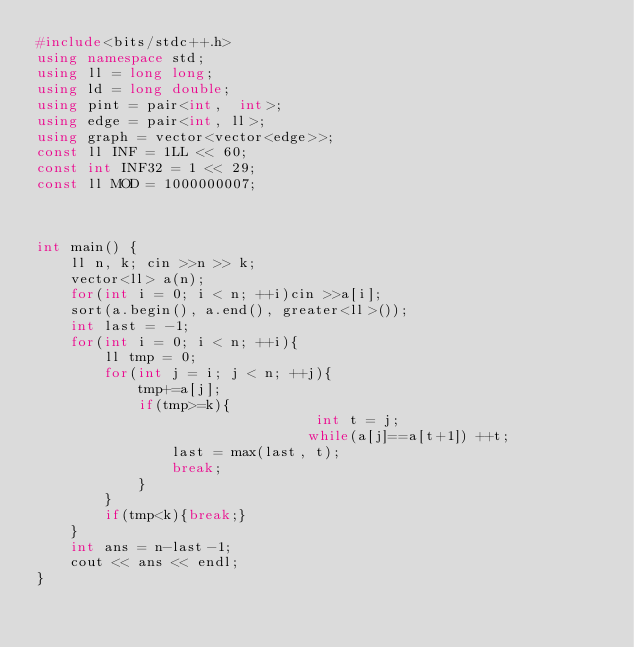<code> <loc_0><loc_0><loc_500><loc_500><_C++_>#include<bits/stdc++.h>
using namespace std;
using ll = long long;
using ld = long double;
using pint = pair<int,  int>;
using edge = pair<int, ll>;
using graph = vector<vector<edge>>;
const ll INF = 1LL << 60;
const int INF32 = 1 << 29;
const ll MOD = 1000000007;



int main() {
	ll n, k; cin >>n >> k;
	vector<ll> a(n);
	for(int i = 0; i < n; ++i)cin >>a[i];
	sort(a.begin(), a.end(), greater<ll>());
	int last = -1;
	for(int i = 0; i < n; ++i){
		ll tmp = 0;
		for(int j = i; j < n; ++j){
			tmp+=a[j];
			if(tmp>=k){
                                 int t = j;
                                while(a[j]==a[t+1]) ++t;
  				last = max(last, t);
				break;
            }
        }
        if(tmp<k){break;}
    }
    int ans = n-last-1;
    cout << ans << endl;
}
</code> 